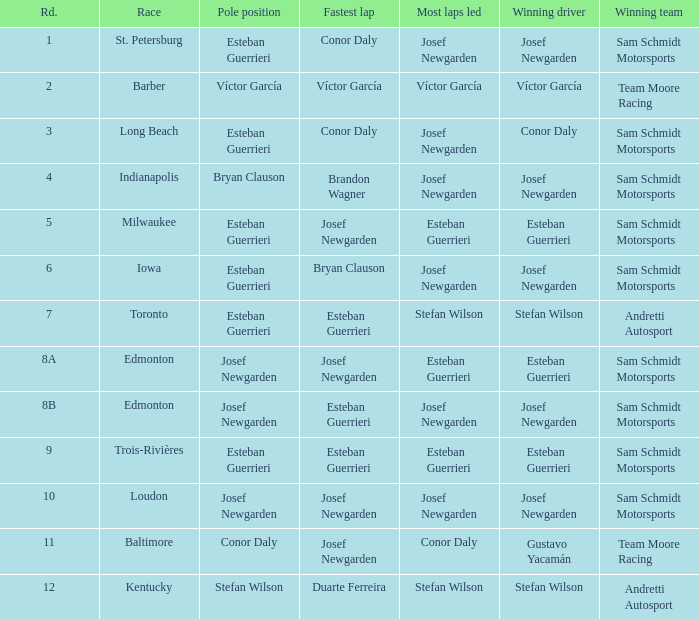Who possessed the pole(s) when esteban guerrieri topped the most laps during round 8a and josef newgarden recorded the speediest lap? Josef Newgarden. 